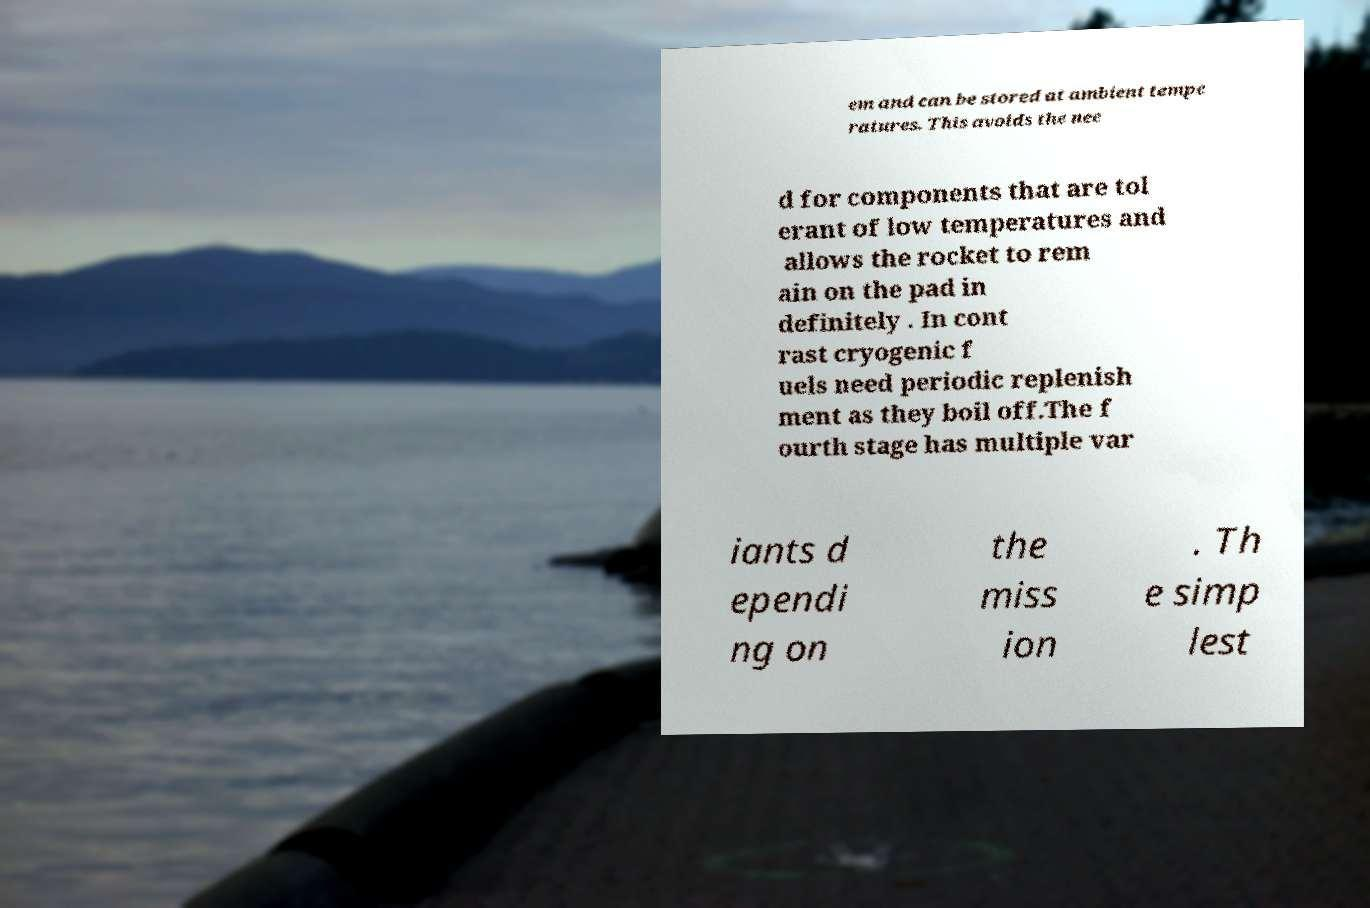There's text embedded in this image that I need extracted. Can you transcribe it verbatim? em and can be stored at ambient tempe ratures. This avoids the nee d for components that are tol erant of low temperatures and allows the rocket to rem ain on the pad in definitely . In cont rast cryogenic f uels need periodic replenish ment as they boil off.The f ourth stage has multiple var iants d ependi ng on the miss ion . Th e simp lest 